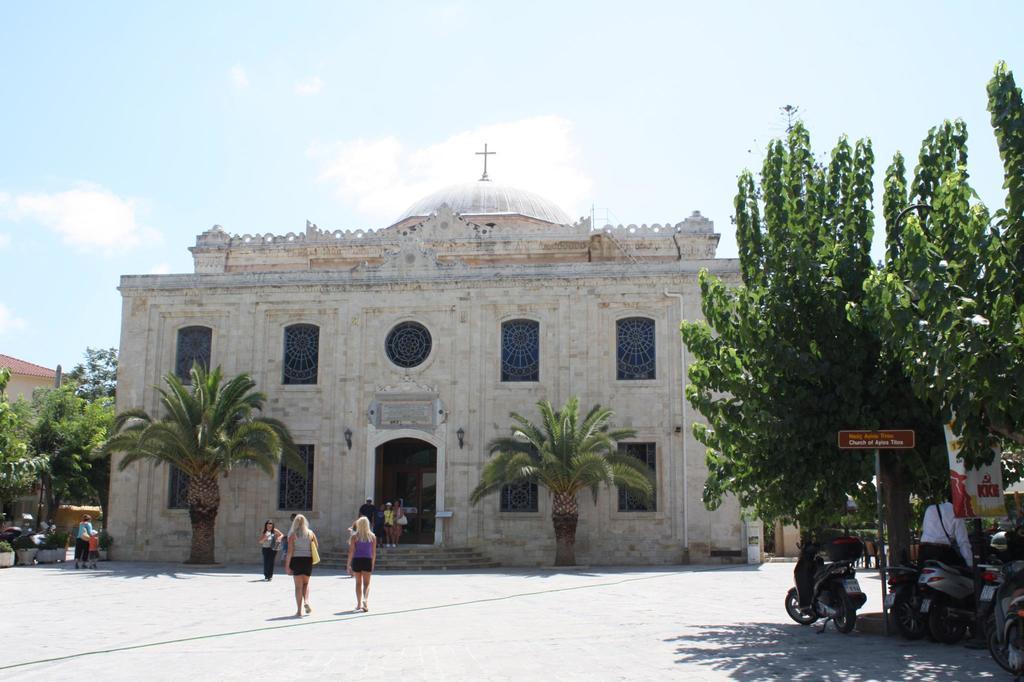In one or two sentences, can you explain what this image depicts? On the right bottom I can see bikes, board, a person and trees on the road. In the foreground I can see a crowd on the road and a building. In the left I can see houseplants. In the background I can see the sky. This image is taken during a sunny day. 